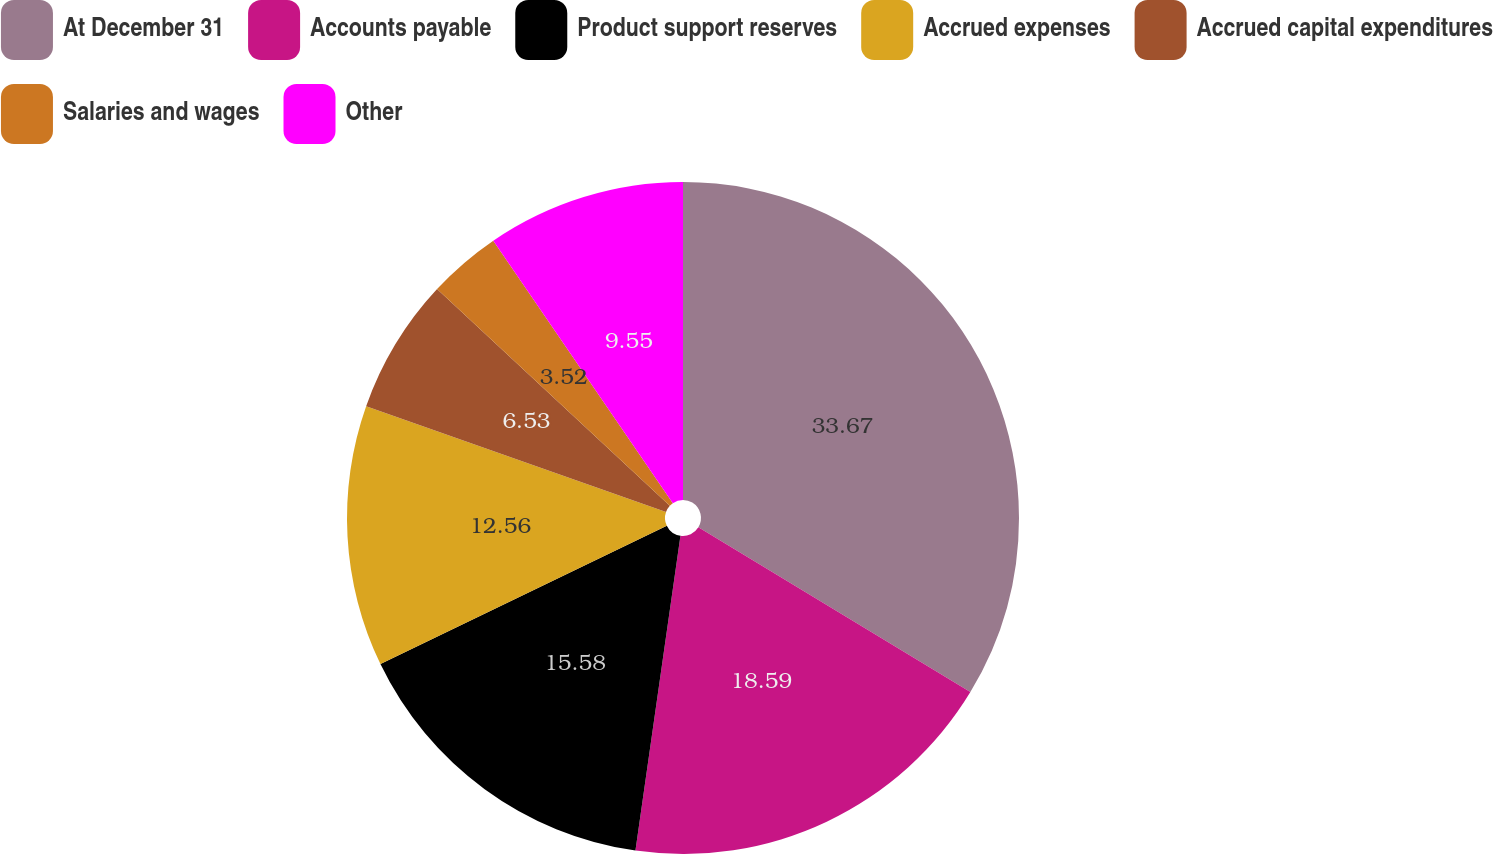Convert chart to OTSL. <chart><loc_0><loc_0><loc_500><loc_500><pie_chart><fcel>At December 31<fcel>Accounts payable<fcel>Product support reserves<fcel>Accrued expenses<fcel>Accrued capital expenditures<fcel>Salaries and wages<fcel>Other<nl><fcel>33.67%<fcel>18.59%<fcel>15.58%<fcel>12.56%<fcel>6.53%<fcel>3.52%<fcel>9.55%<nl></chart> 